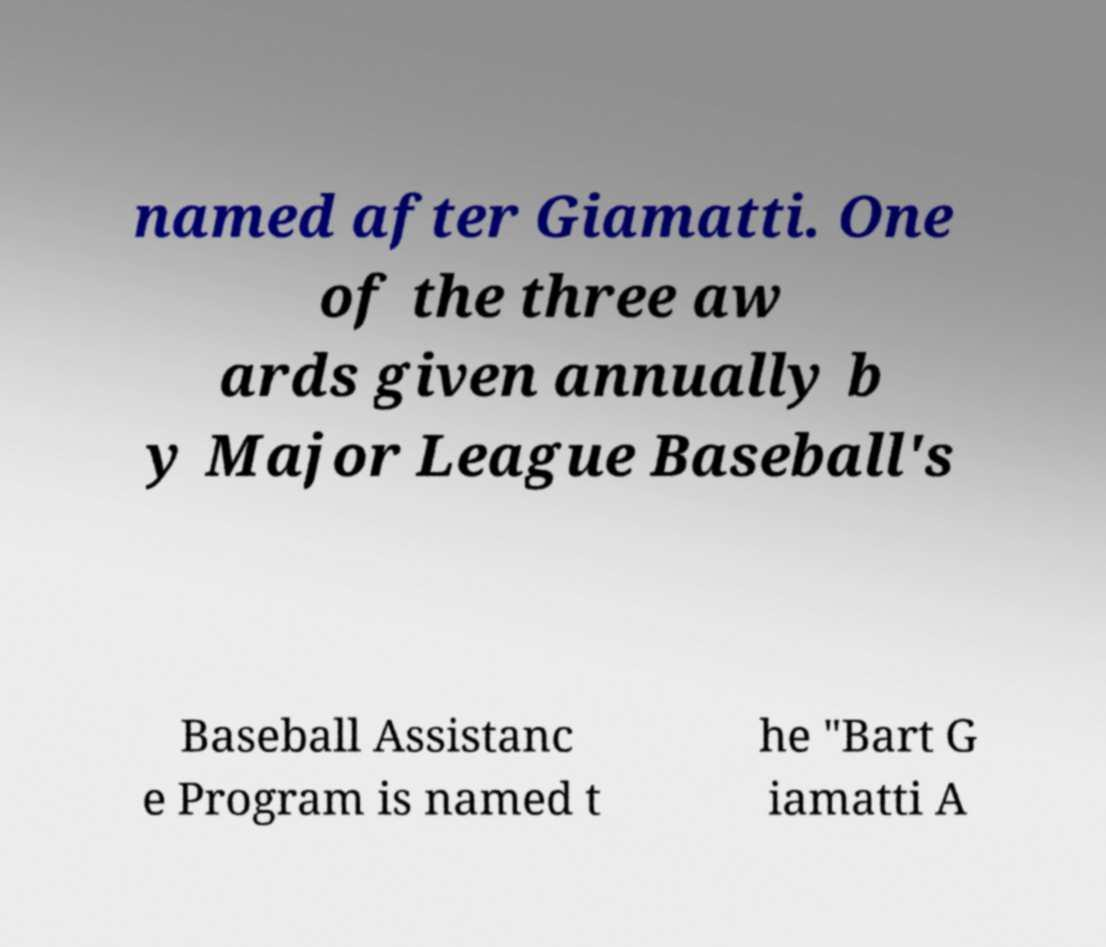For documentation purposes, I need the text within this image transcribed. Could you provide that? named after Giamatti. One of the three aw ards given annually b y Major League Baseball's Baseball Assistanc e Program is named t he "Bart G iamatti A 